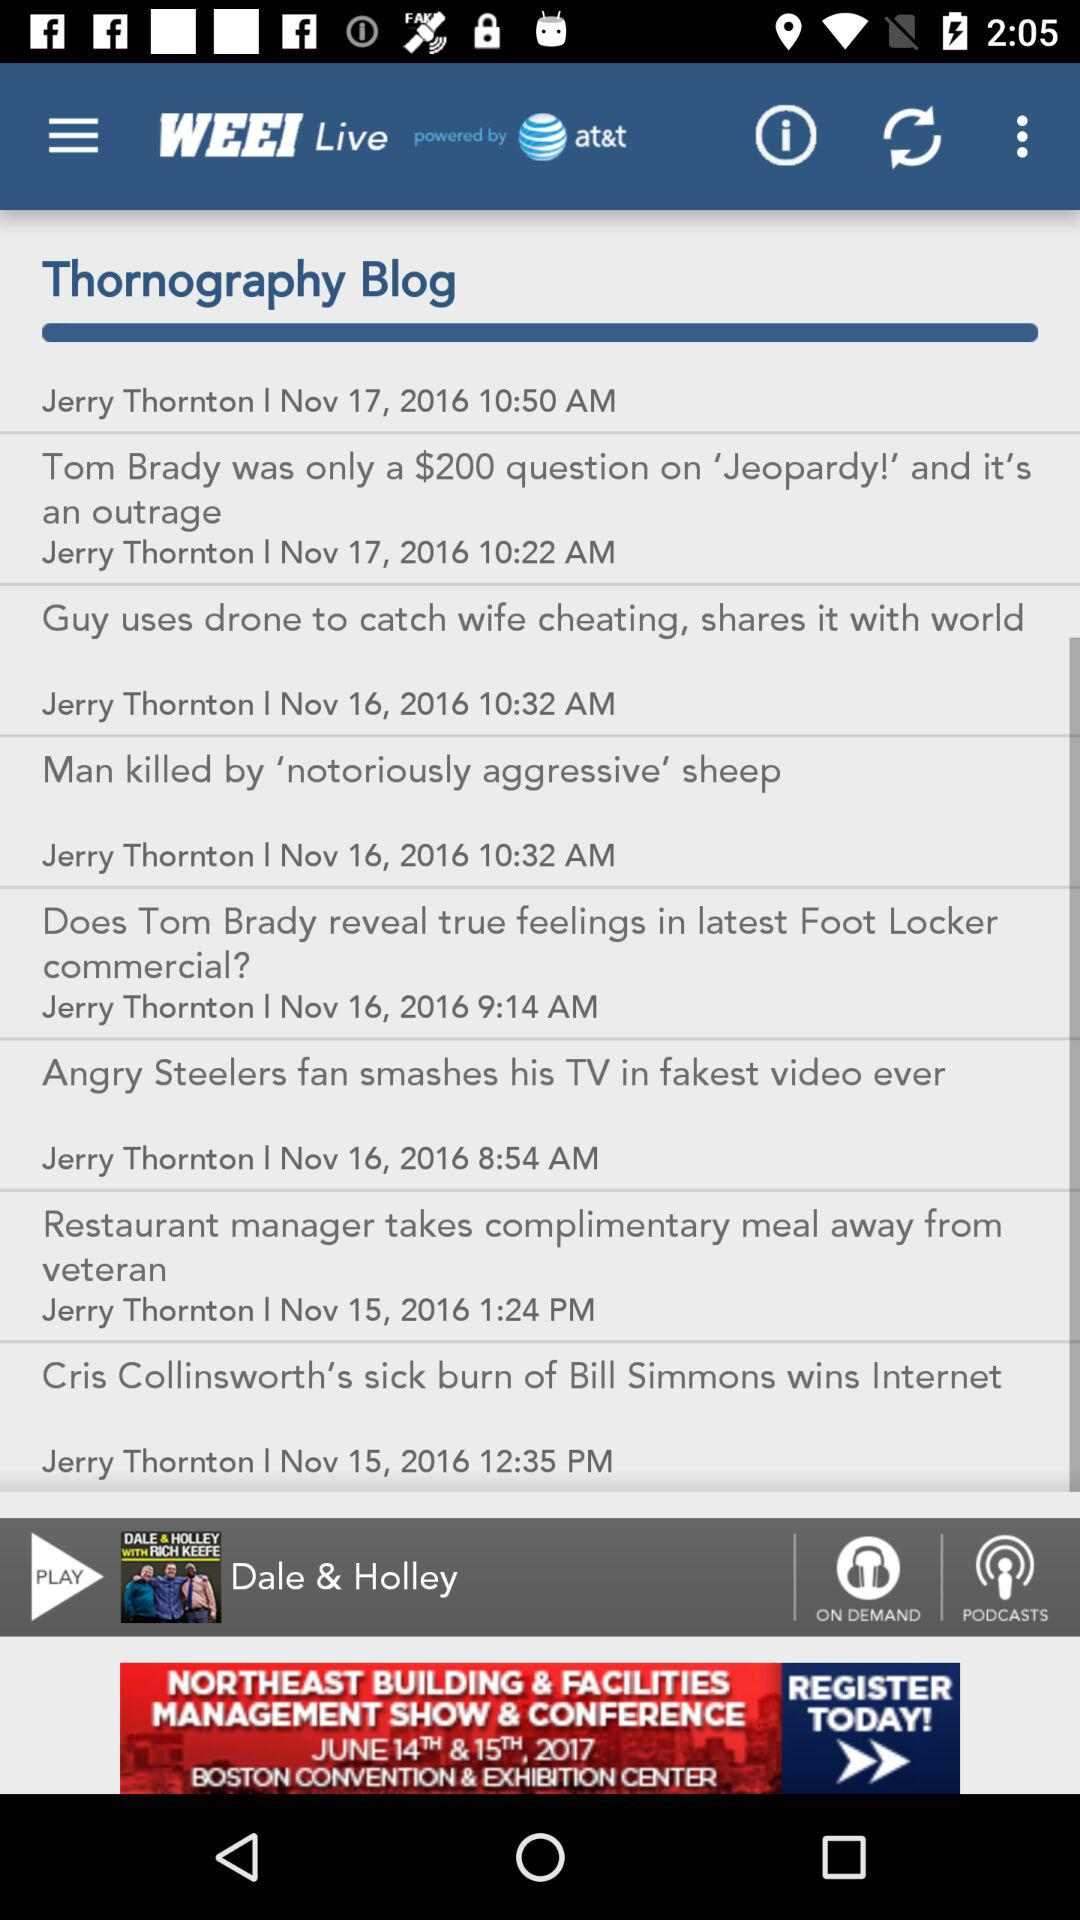Who wrote all of these blogs? All of these blogs were written by Jerry Thornton. 